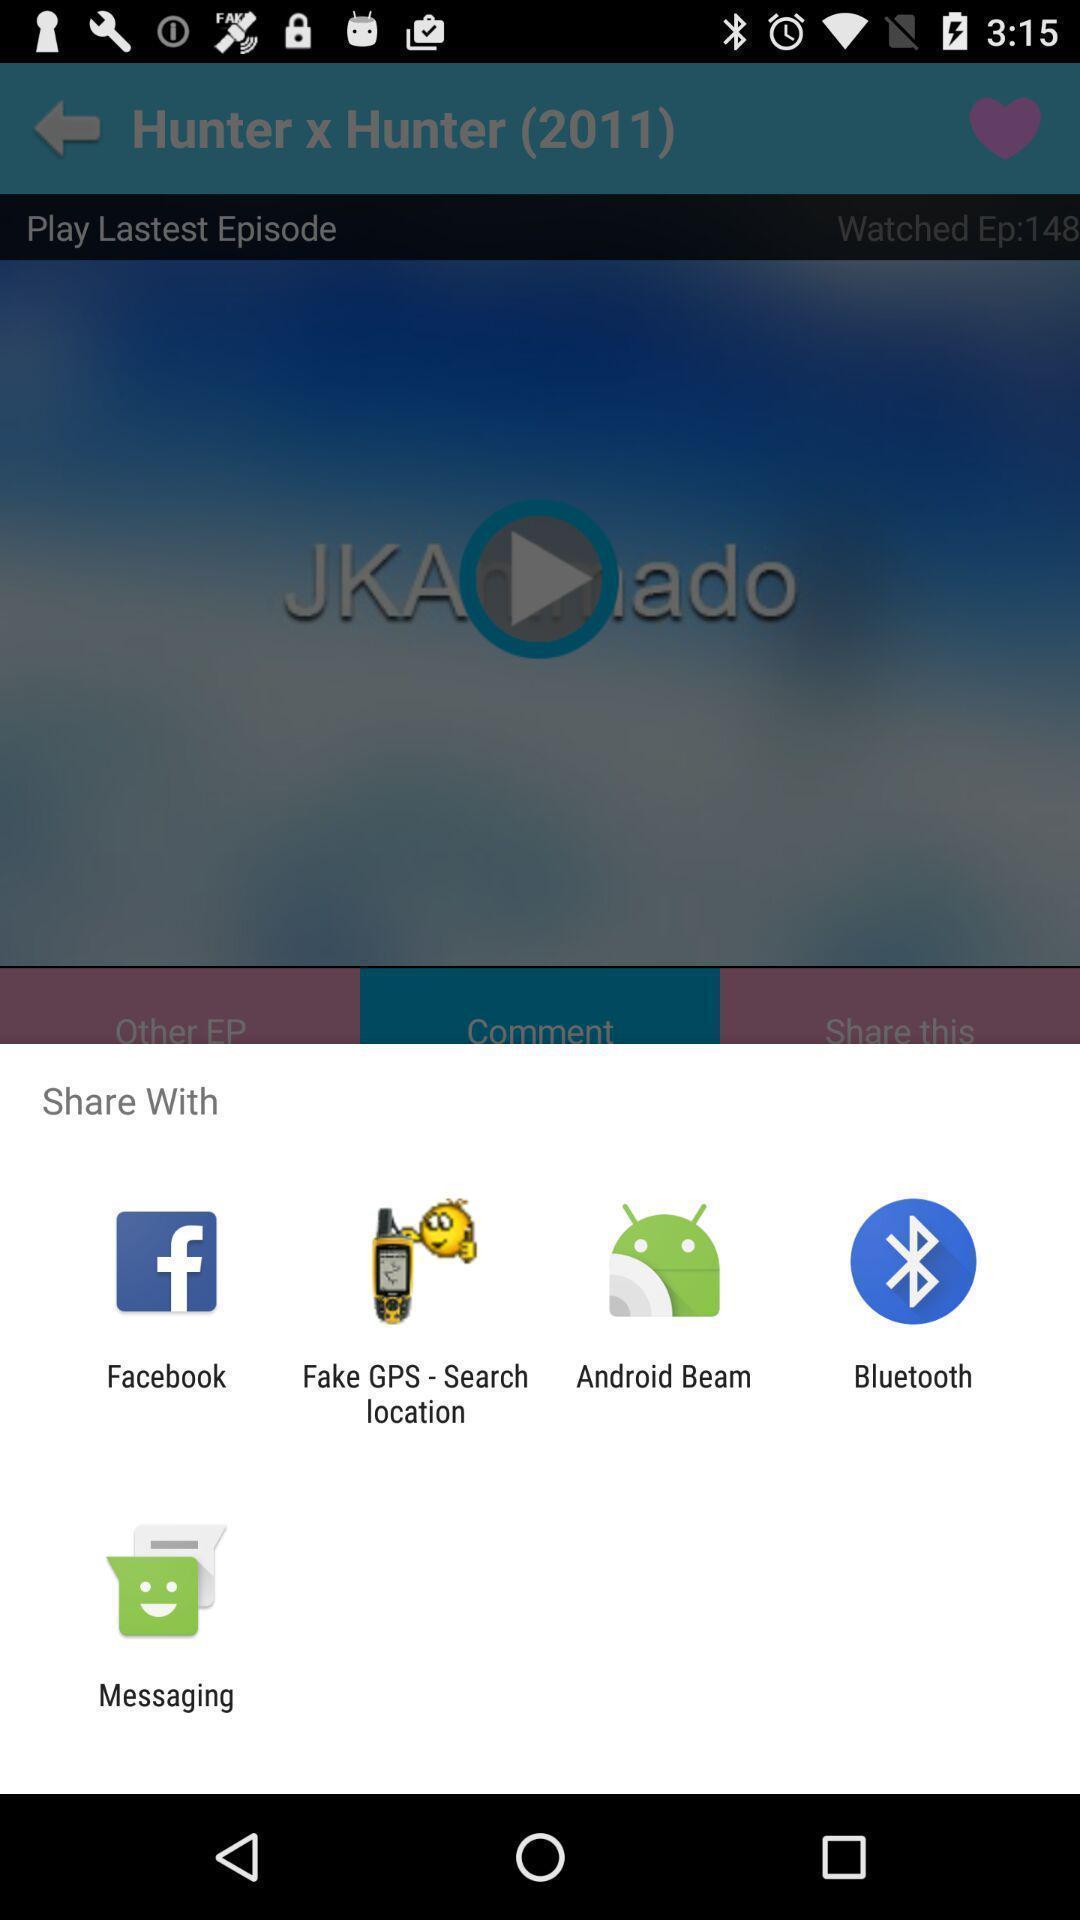Provide a detailed account of this screenshot. Pop-up asking to share with different apps. 